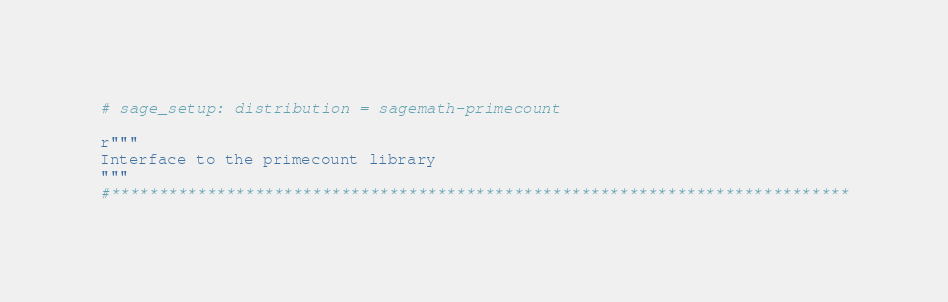<code> <loc_0><loc_0><loc_500><loc_500><_Cython_># sage_setup: distribution = sagemath-primecount

r"""
Interface to the primecount library
"""
#*****************************************************************************</code> 